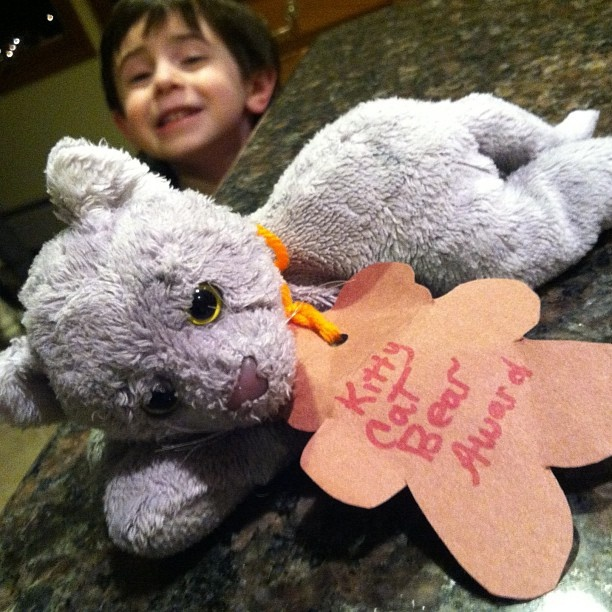Describe the objects in this image and their specific colors. I can see teddy bear in black, lightgray, darkgray, and gray tones, dining table in black, darkgreen, and gray tones, and people in black, brown, and maroon tones in this image. 